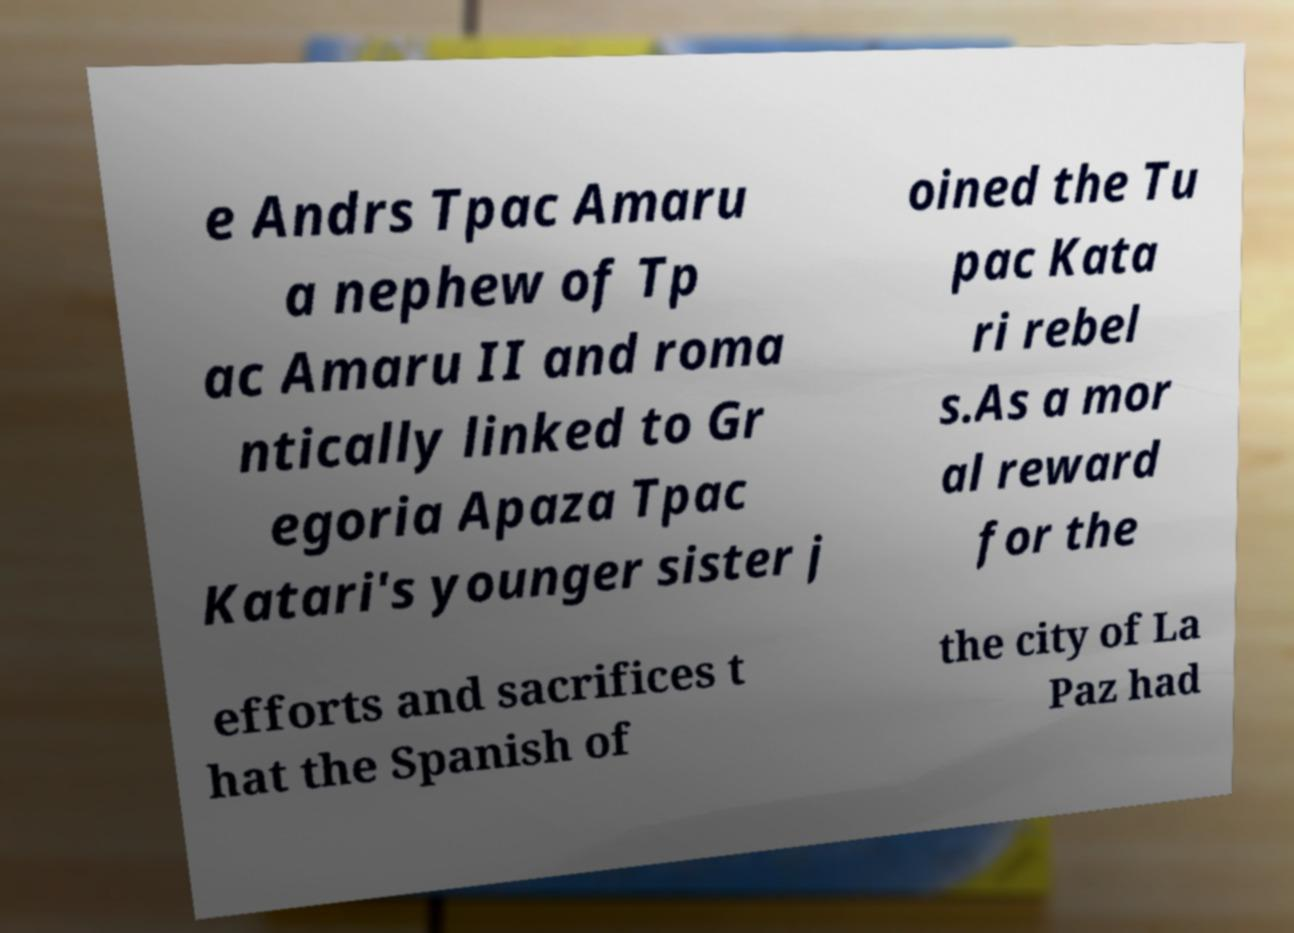Please identify and transcribe the text found in this image. e Andrs Tpac Amaru a nephew of Tp ac Amaru II and roma ntically linked to Gr egoria Apaza Tpac Katari's younger sister j oined the Tu pac Kata ri rebel s.As a mor al reward for the efforts and sacrifices t hat the Spanish of the city of La Paz had 